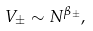Convert formula to latex. <formula><loc_0><loc_0><loc_500><loc_500>V _ { \pm } \sim N ^ { \beta _ { \pm } } ,</formula> 